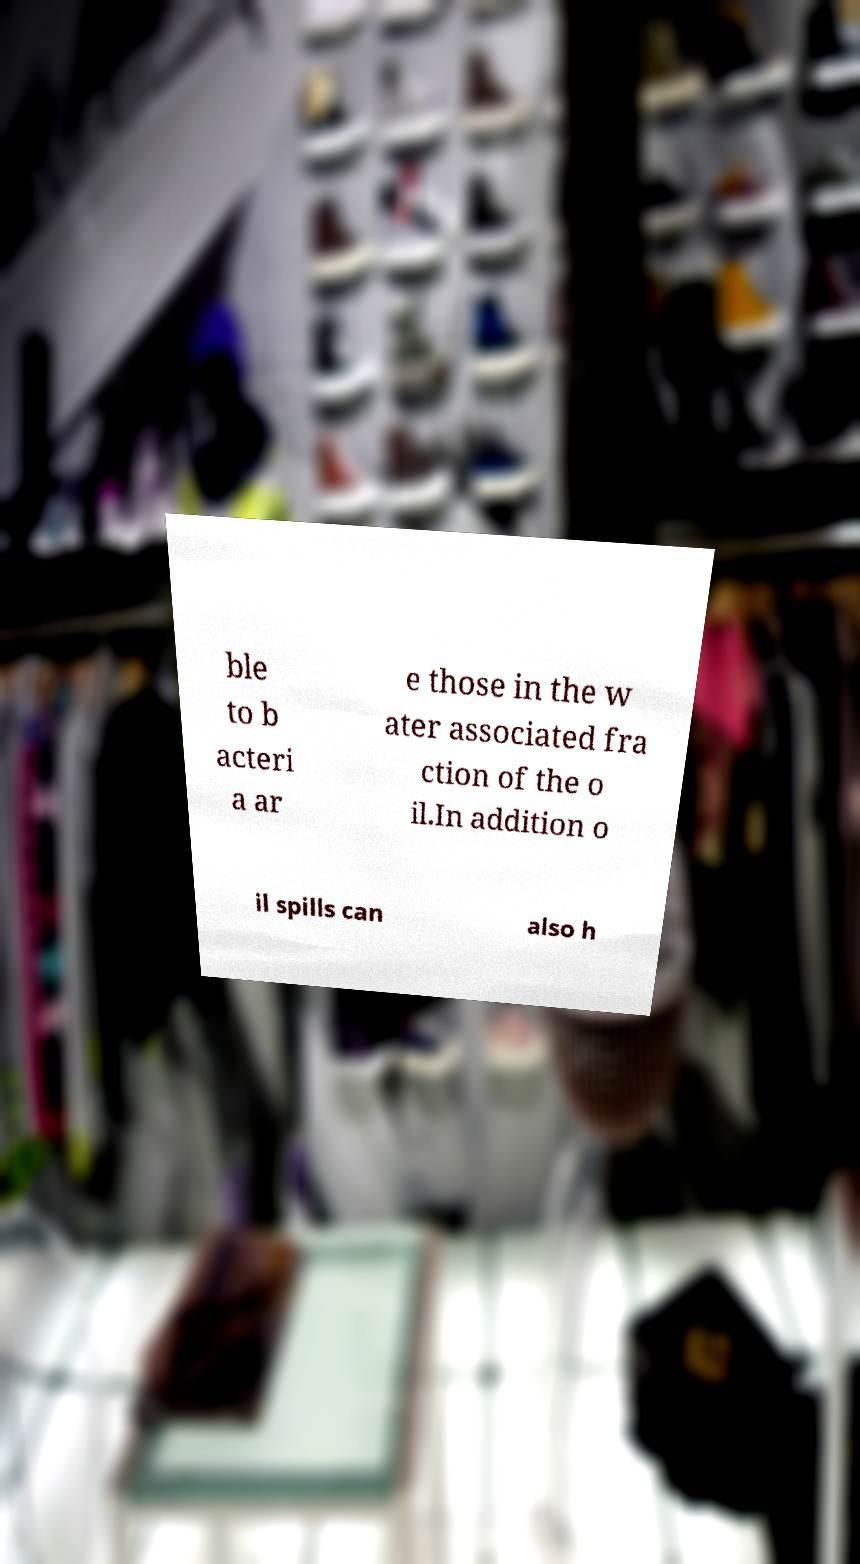Could you assist in decoding the text presented in this image and type it out clearly? ble to b acteri a ar e those in the w ater associated fra ction of the o il.In addition o il spills can also h 